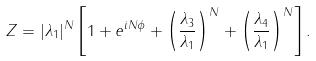Convert formula to latex. <formula><loc_0><loc_0><loc_500><loc_500>Z = | \lambda _ { 1 } | ^ { N } \left [ { 1 + e ^ { i N \phi } + \left ( \frac { \lambda _ { 3 } } { \lambda _ { 1 } } \right ) ^ { N } + \left ( \frac { \lambda _ { 4 } } { \lambda _ { 1 } } \right ) ^ { N } } \right ] .</formula> 